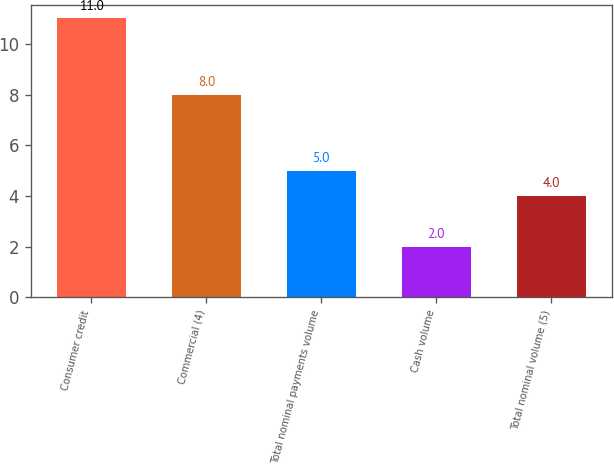Convert chart. <chart><loc_0><loc_0><loc_500><loc_500><bar_chart><fcel>Consumer credit<fcel>Commercial (4)<fcel>Total nominal payments volume<fcel>Cash volume<fcel>Total nominal volume (5)<nl><fcel>11<fcel>8<fcel>5<fcel>2<fcel>4<nl></chart> 